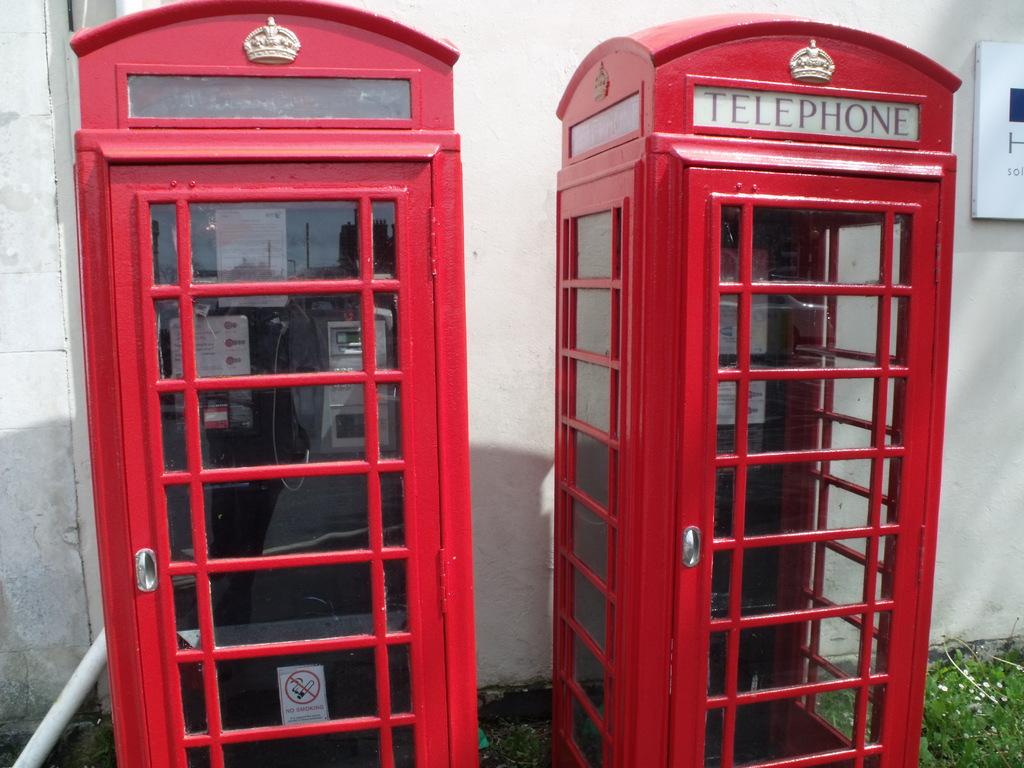What kind of booth is this?
Give a very brief answer. Telephone. What is on the sign?
Your answer should be very brief. Telephone. 